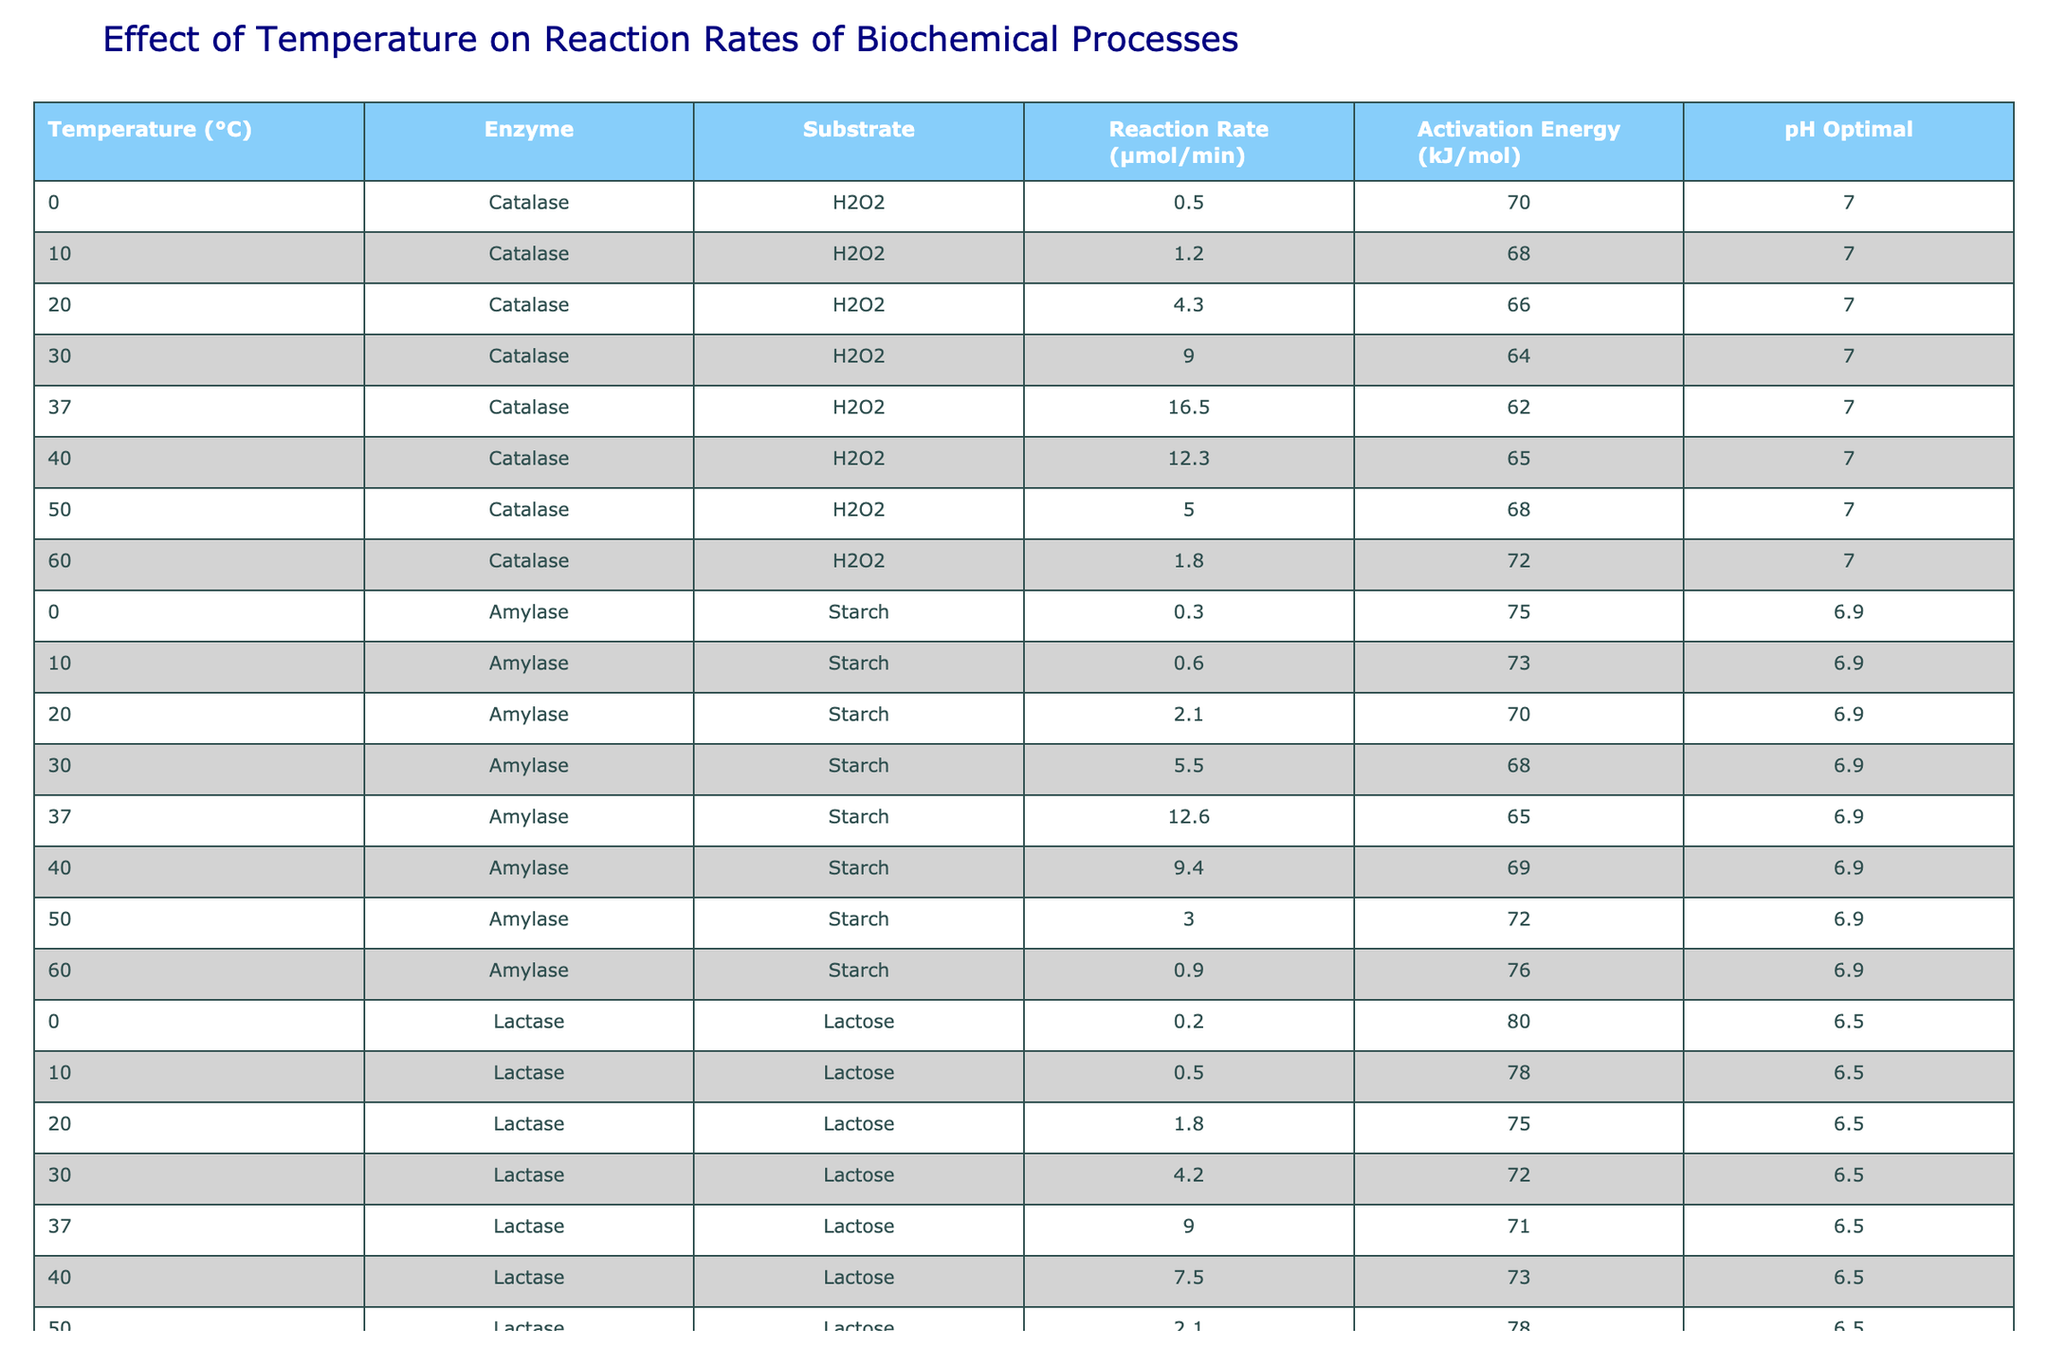What is the reaction rate of Catalase at 37°C? The table shows the reaction rates for Catalase at various temperatures, and at 37°C, the corresponding reaction rate is indicated as 16.5 µmol/min.
Answer: 16.5 µmol/min What is the optimal pH for Amylase? The table specifies the optimal pH for Amylase as 6.9.
Answer: 6.9 What is the activation energy for Lactase at 20°C? According to the table, the activation energy listed for Lactase at 20°C is 75 kJ/mol.
Answer: 75 kJ/mol At what temperature does the reaction rate of Catalase decline after reaching its peak? The peak reaction rate of Catalase occurs at 37°C with 16.5 µmol/min, and it declines to 12.3 µmol/min at 40°C.
Answer: 40°C What is the average reaction rate of Amylase at temperatures below 30°C? The reaction rates for Amylase at 0°C, 10°C, and 20°C are 0.3, 0.6, and 2.1 µmol/min respectively. The average is (0.3 + 0.6 + 2.1) / 3 = 1.0 µmol/min.
Answer: 1.0 µmol/min Is the reaction rate of Lactase at 60°C higher than that of Amylase at the same temperature? The table indicates that the reaction rate of Lactase at 60°C is 0.4 µmol/min and for Amylase at 60°C is 0.9 µmol/min, therefore, Lactase's reaction rate is lower.
Answer: No What is the difference in the reaction rate of Catalase between 30°C and 40°C? The reaction rate for Catalase at 30°C is 9.0 µmol/min and at 40°C is 12.3 µmol/min, thus, the difference is 12.3 - 9.0 = 3.3 µmol/min.
Answer: 3.3 µmol/min Which enzyme has the highest reaction rate at 37°C? At 37°C, Catalase has a reaction rate of 16.5 µmol/min, while Amylase and Lactase have 12.6 µmol/min and 9.0 µmol/min respectively, making Catalase the highest.
Answer: Catalase What is the trend of reaction rates for Amylase as temperature increases from 0°C to 40°C? The reaction rates for Amylase increase from 0.3 µmol/min at 0°C to a maximum of 12.6 µmol/min at 37°C and then decrease to 9.4 µmol/min at 40°C, showing an overall increase followed by a decrease.
Answer: Increase then decrease Which enzyme has the lowest reaction rate recorded in the table? Upon reviewing the table, Lactase at 0°C has the lowest reaction rate at 0.2 µmol/min.
Answer: Lactase at 0°C 